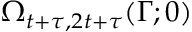Convert formula to latex. <formula><loc_0><loc_0><loc_500><loc_500>\Omega _ { t + \tau , 2 t + \tau } ( \Gamma ; 0 )</formula> 